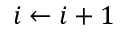<formula> <loc_0><loc_0><loc_500><loc_500>i \leftarrow i + 1</formula> 